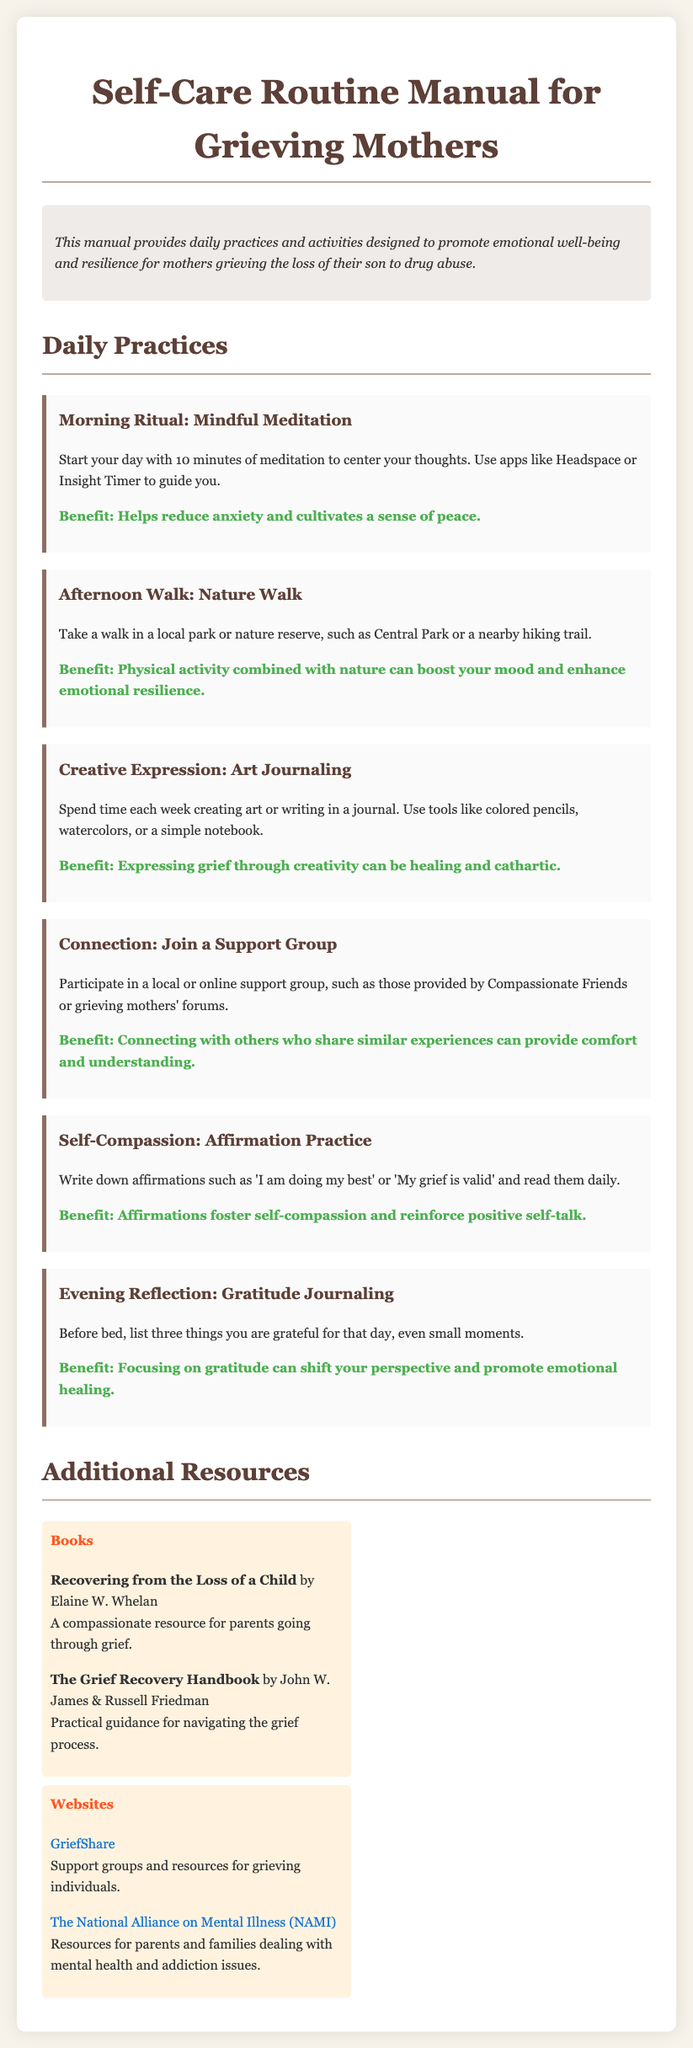What is the title of the manual? The title of the manual is found in the heading of the document.
Answer: Self-Care Routine Manual for Grieving Mothers How long should the morning meditation last? The length of the morning meditation is specified in the daily practices section.
Answer: 10 minutes What type of support is suggested to connect with others? The type of support mentioned relates to activities that allow connection with similar individuals.
Answer: Support Group What should you write daily for self-compassion? The specific practice highlighted under self-compassion indicates what to write for daily reinforcement.
Answer: Affirmations Name one benefit of taking a nature walk. The benefits of activities can be retrieved from their respective sections in the document.
Answer: Boost your mood What is one suggested activity for creative expression? The practice for creative expression includes specific types of activities mentioned in the document.
Answer: Art Journaling What should be listed in the gratitude journal? The document advises on what to focus on during evening reflection.
Answer: Three things you are grateful for Which book is recommended for recovering from the loss of a child? The recommendations in the resource section provide specific titles of relevant books.
Answer: Recovering from the Loss of a Child What color is primarily used in the document for headings? The document describes the color used for specific text elements, particularly headings.
Answer: #5d4037 